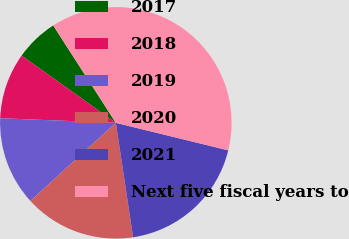Convert chart to OTSL. <chart><loc_0><loc_0><loc_500><loc_500><pie_chart><fcel>2017<fcel>2018<fcel>2019<fcel>2020<fcel>2021<fcel>Next five fiscal years to<nl><fcel>6.04%<fcel>9.23%<fcel>12.42%<fcel>15.6%<fcel>18.79%<fcel>37.92%<nl></chart> 